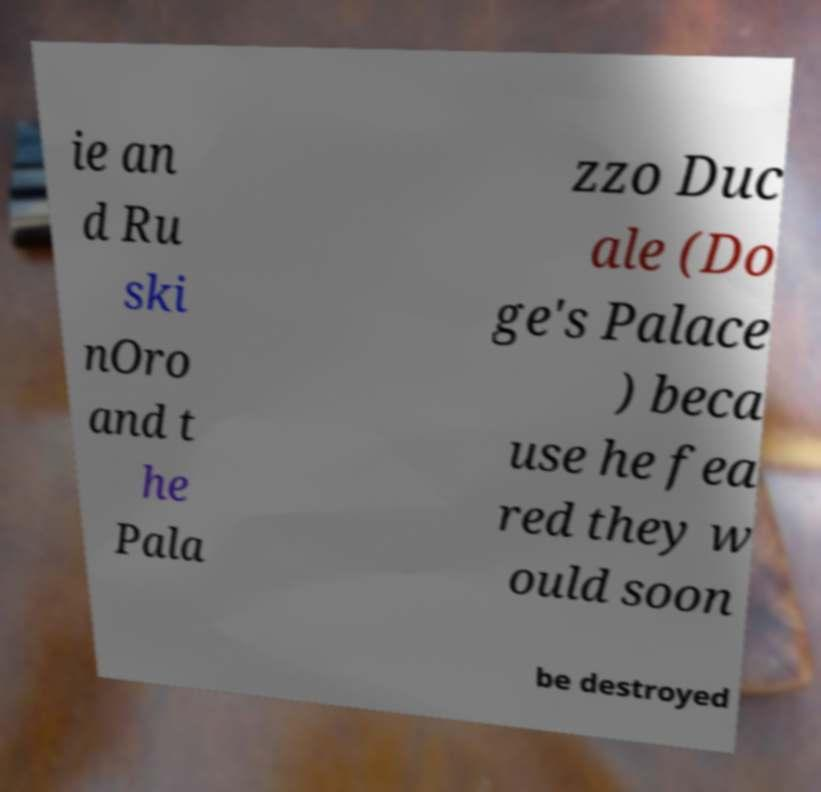I need the written content from this picture converted into text. Can you do that? ie an d Ru ski nOro and t he Pala zzo Duc ale (Do ge's Palace ) beca use he fea red they w ould soon be destroyed 